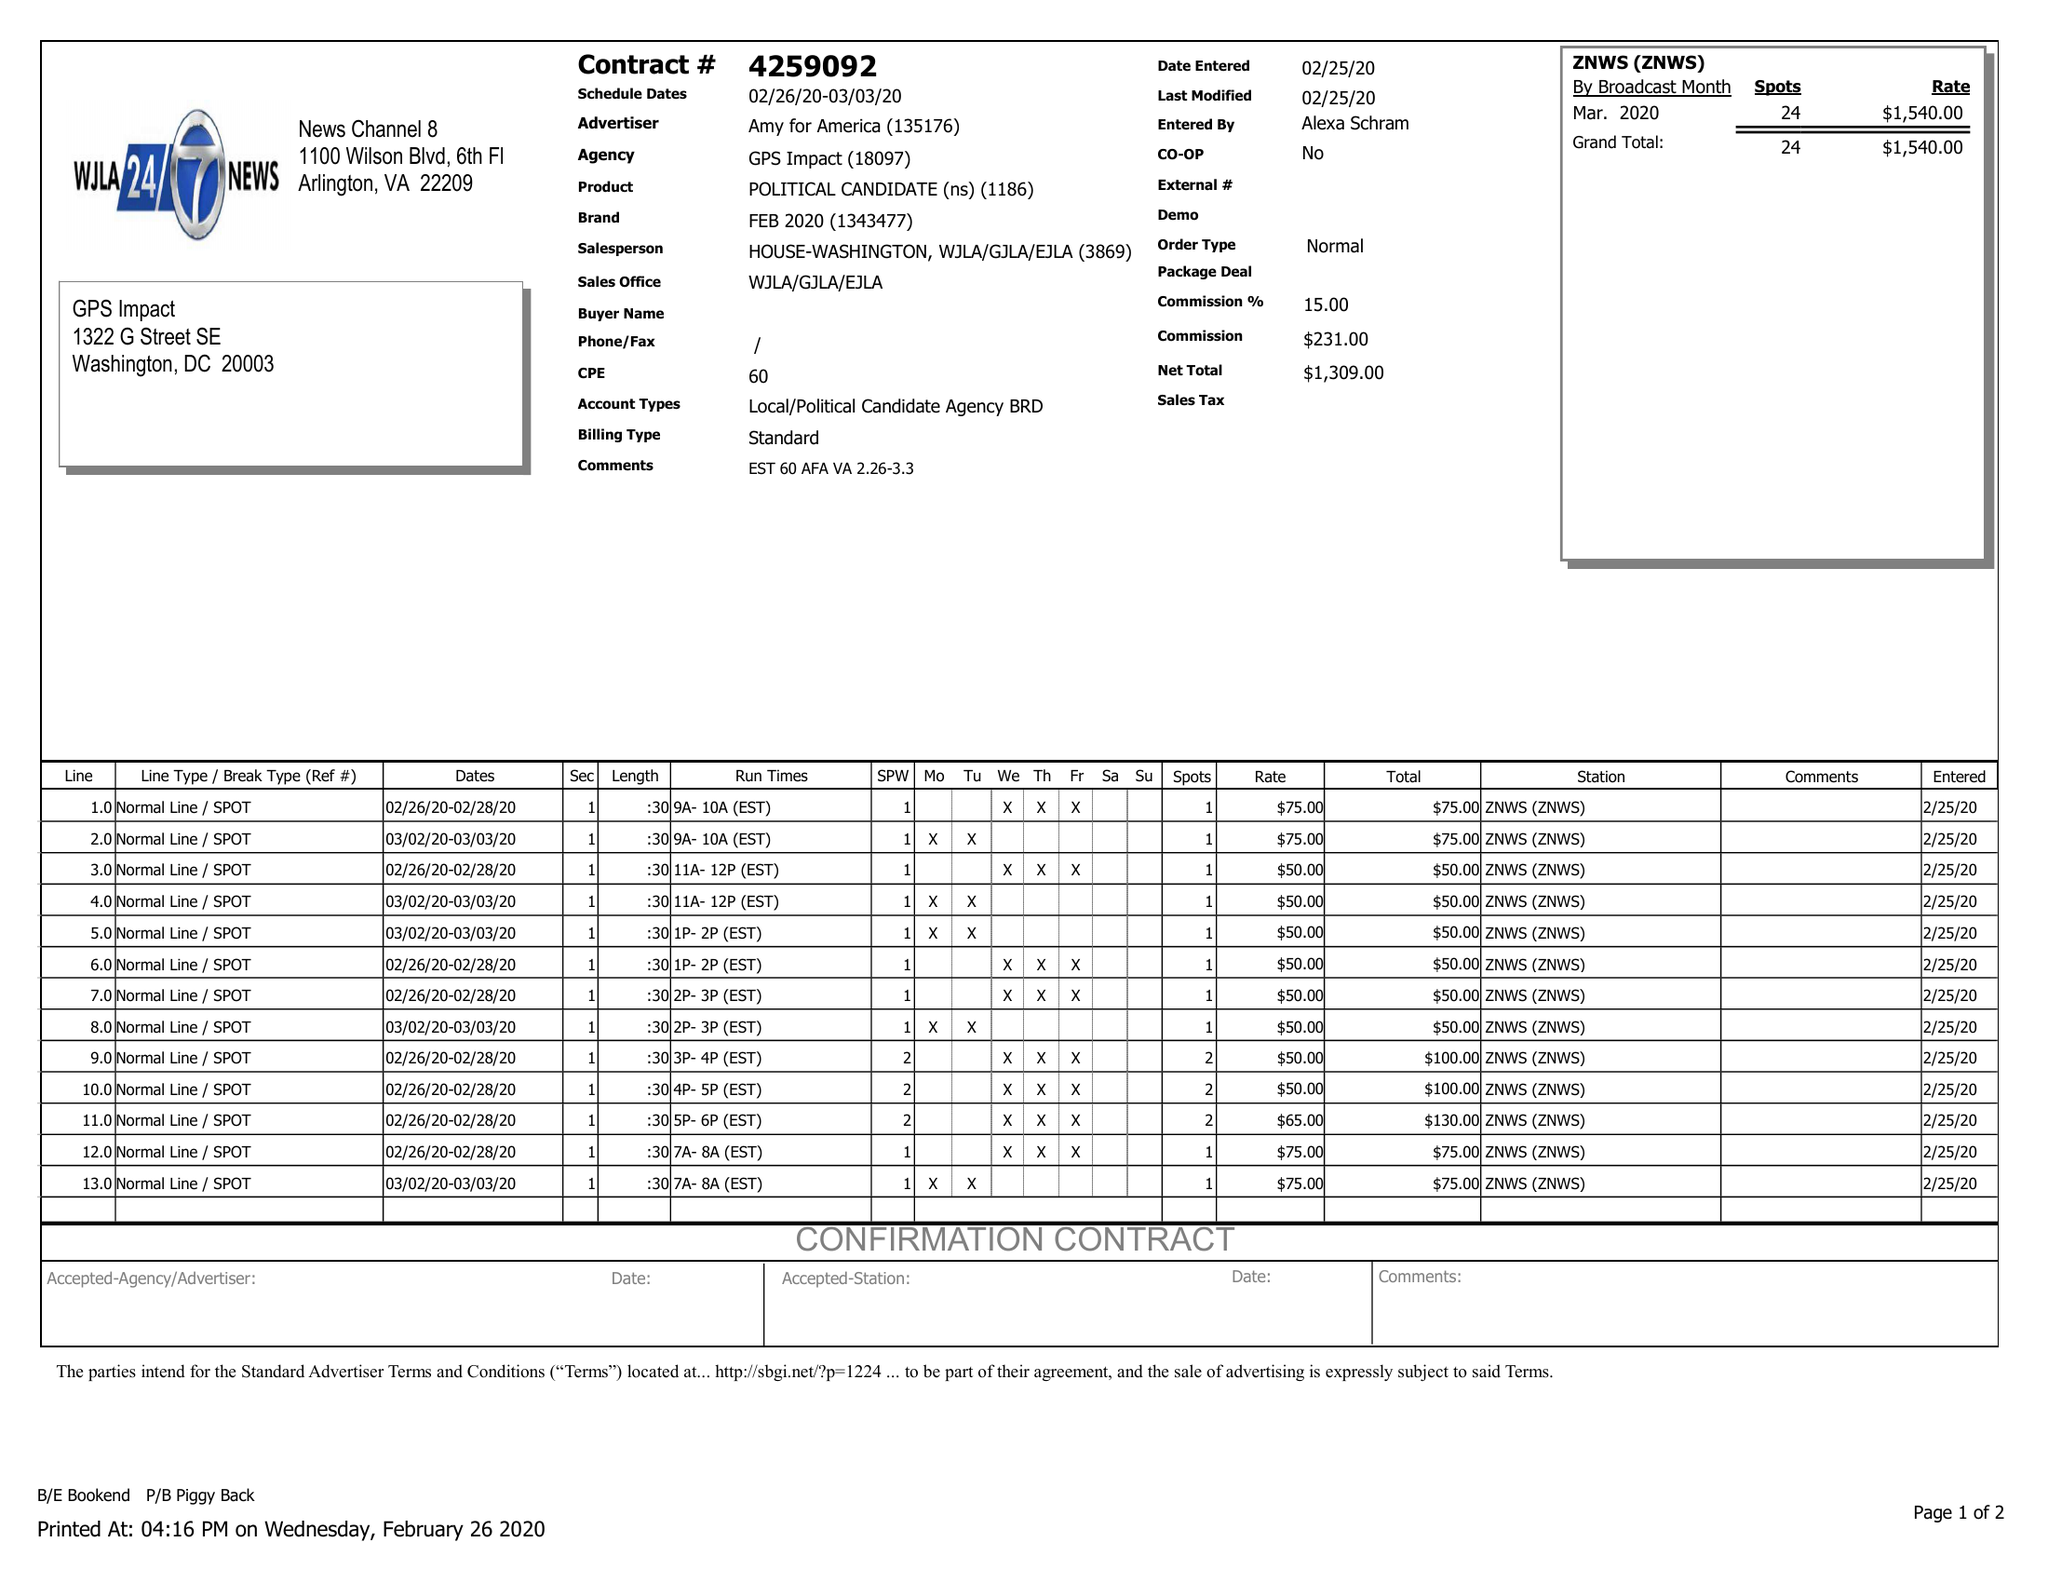What is the value for the flight_from?
Answer the question using a single word or phrase. 02/26/20 